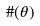<formula> <loc_0><loc_0><loc_500><loc_500>\# ( \theta )</formula> 